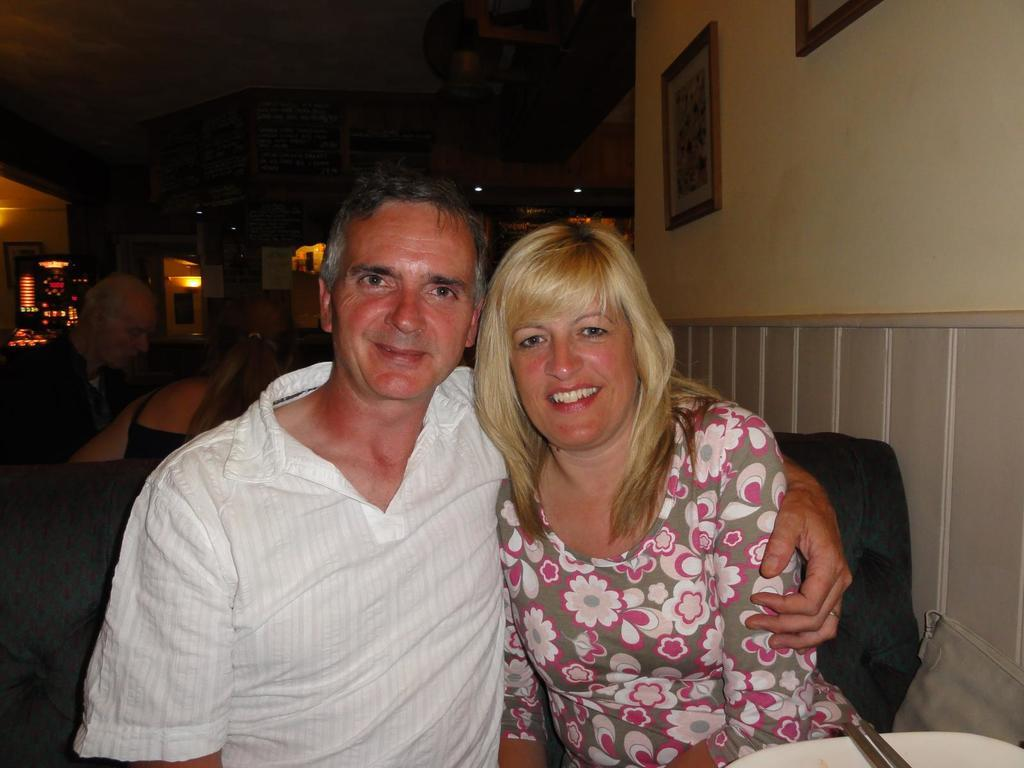What are the people in the front of the image doing? The persons in the front of the image are sitting and smiling. Can you describe the people in the background of the image? There are persons sitting in the background of the image. What can be seen in the background of the image? There are lights visible in the background. What is on the right side of the image? There are frames on the wall on the right side of the image. What is the title of the book the person in the image is reading? There is no book visible in the image, so it is not possible to determine the title. 